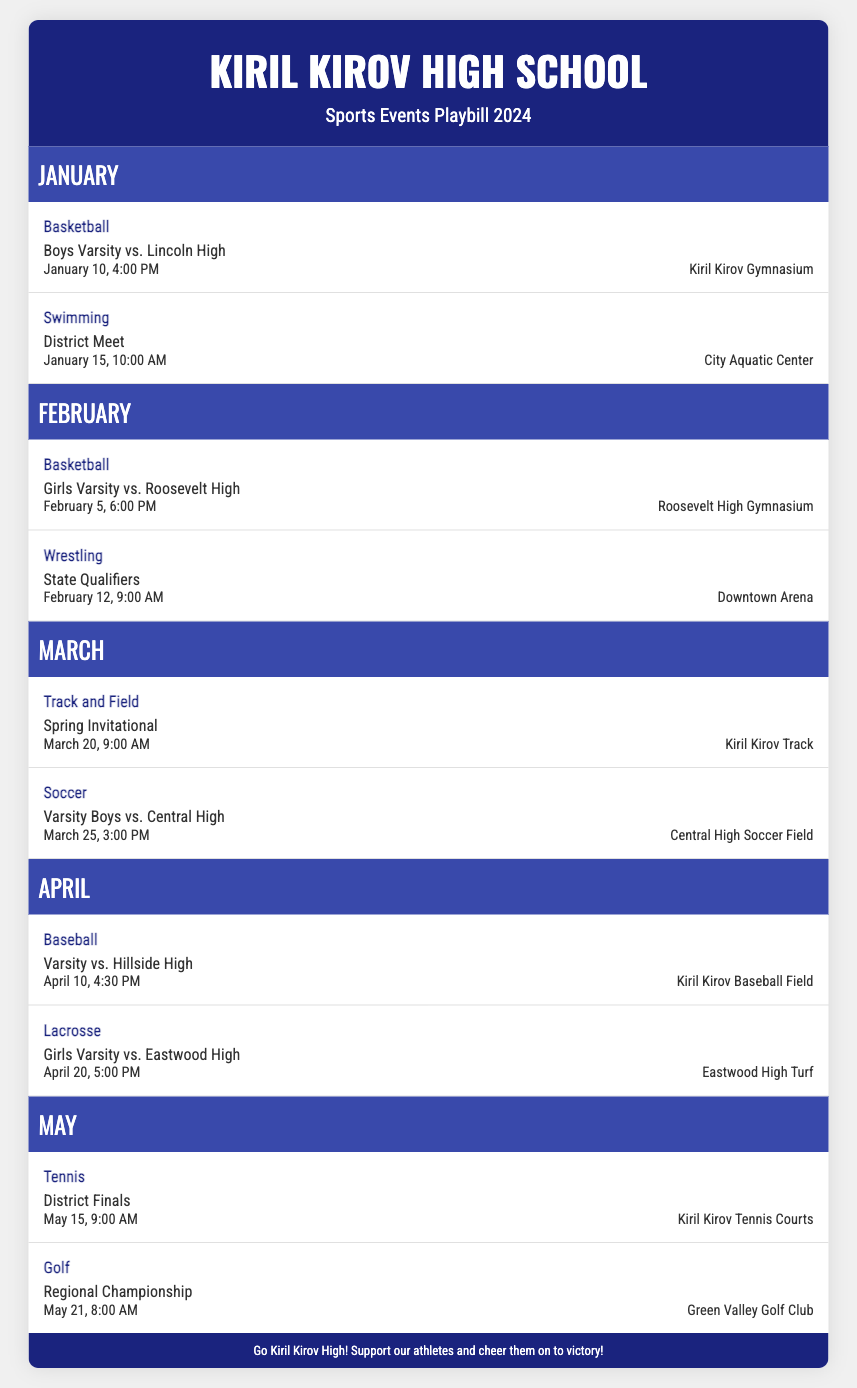What is the first basketball event? The first basketball event listed is "Boys Varsity vs. Lincoln High" on January 10 at 4:00 PM.
Answer: Boys Varsity vs. Lincoln High When is the District Meet for swimming? The District Meet for swimming is scheduled for January 15 at 10:00 AM.
Answer: January 15, 10:00 AM How many wrestling events are there in the document? There is one wrestling event in the document, which is the State Qualifiers on February 12.
Answer: 1 What sport is scheduled on March 20? The sport scheduled for March 20 is "Track and Field" with the Spring Invitational.
Answer: Track and Field What event takes place on May 15? The event on May 15 is the "District Finals" for tennis at 9:00 AM.
Answer: District Finals Which sport has the earliest event in the schedule? The earliest event in the schedule is the swimming District Meet on January 15 at 10:00 AM.
Answer: Swimming What is featured at the footer of the Playbill? The footer encourages support for the athletes from Kiril Kirov High.
Answer: Support our athletes 